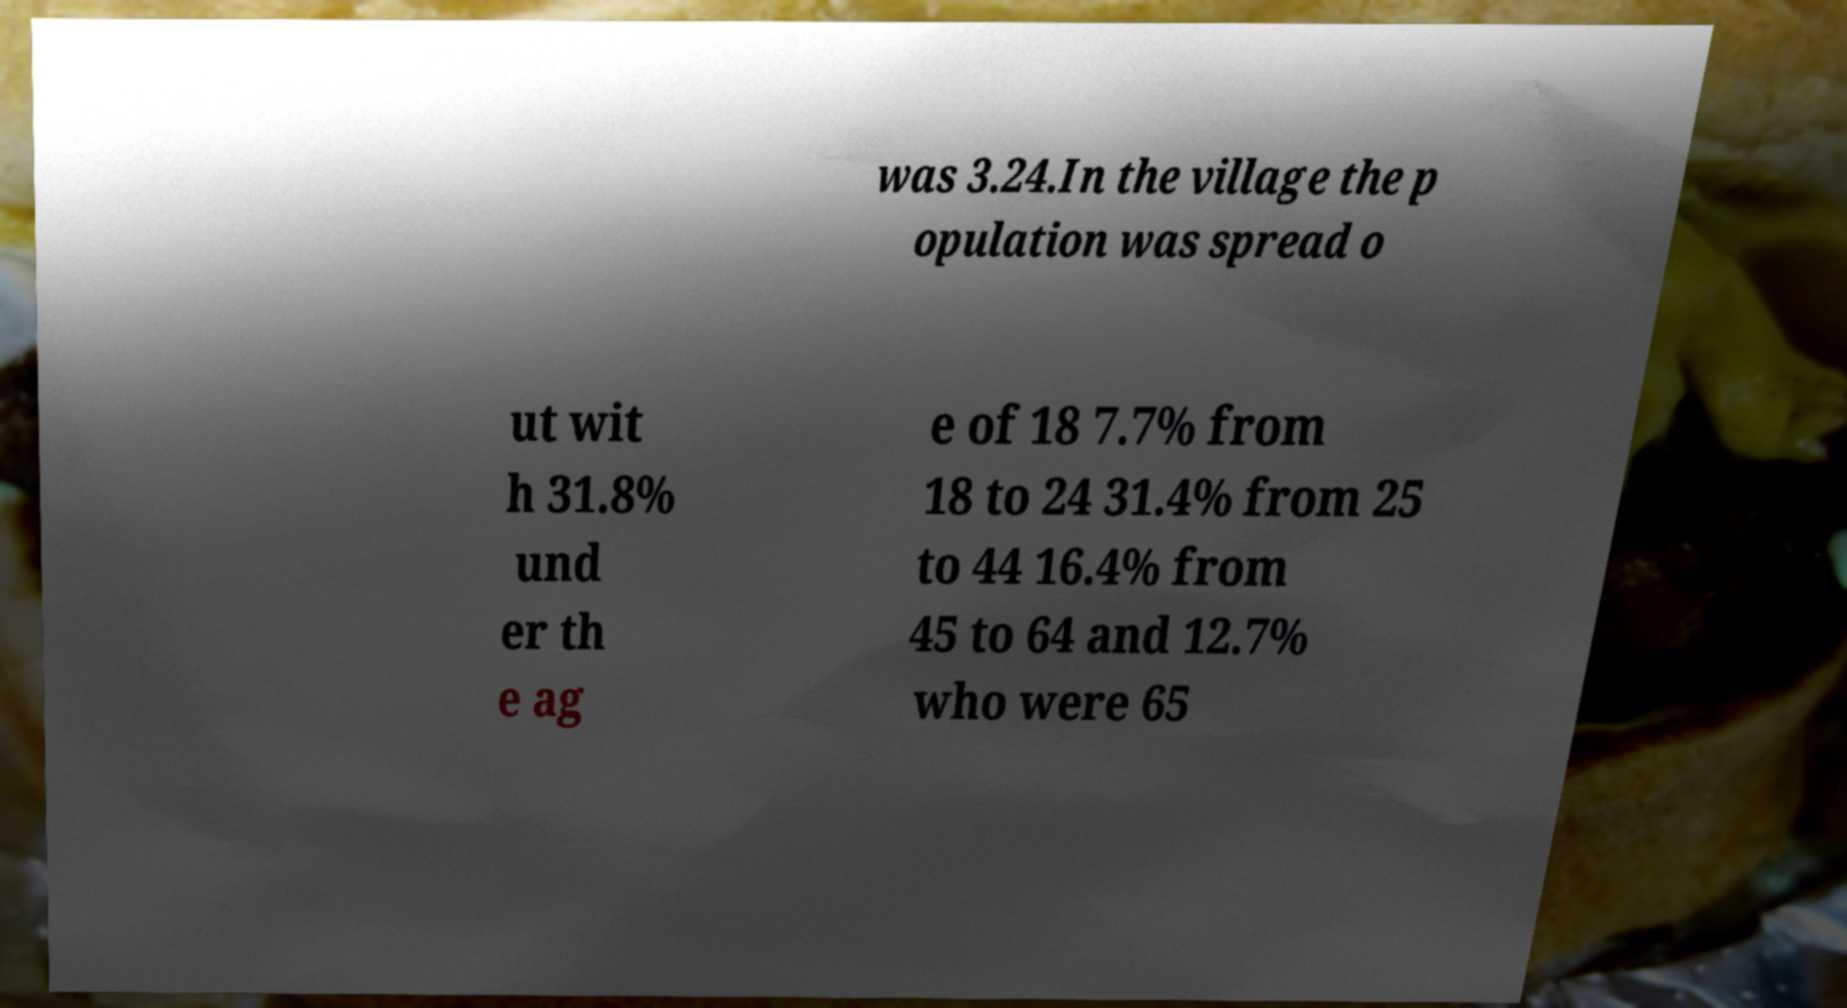I need the written content from this picture converted into text. Can you do that? was 3.24.In the village the p opulation was spread o ut wit h 31.8% und er th e ag e of 18 7.7% from 18 to 24 31.4% from 25 to 44 16.4% from 45 to 64 and 12.7% who were 65 